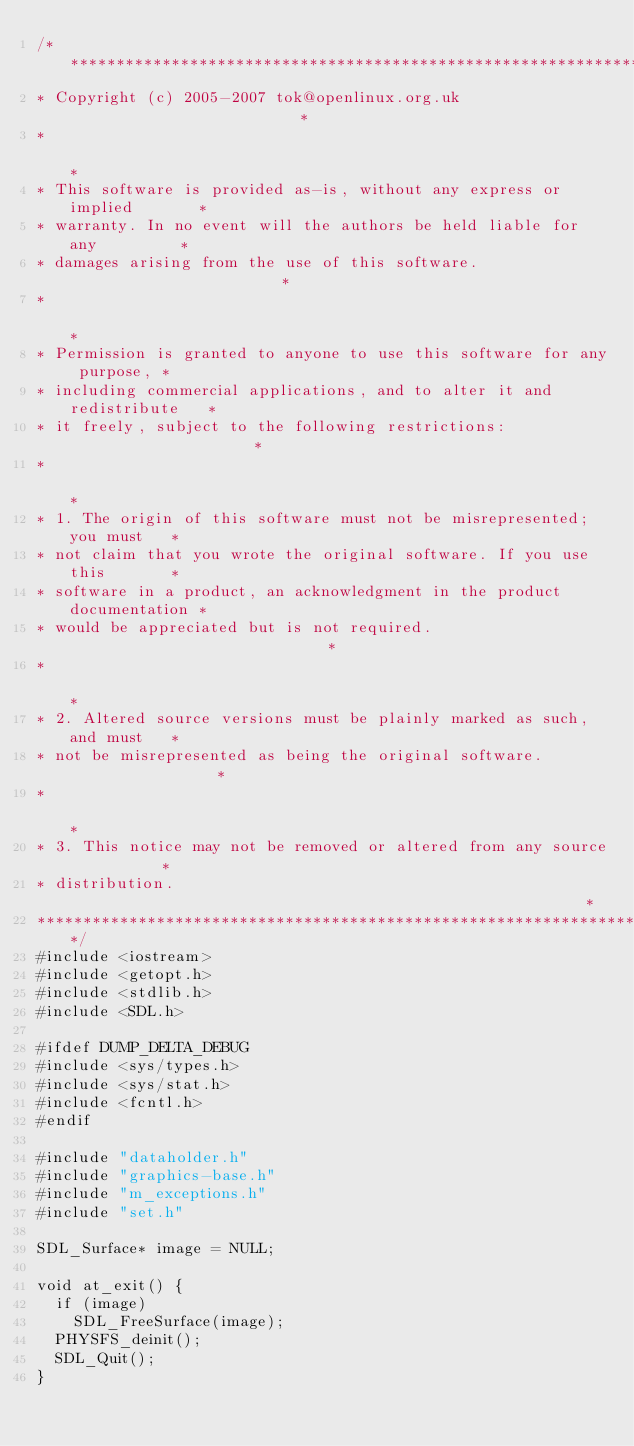Convert code to text. <code><loc_0><loc_0><loc_500><loc_500><_C++_>/************************************************************************
* Copyright (c) 2005-2007 tok@openlinux.org.uk                          *
*                                                                       *
* This software is provided as-is, without any express or implied       *
* warranty. In no event will the authors be held liable for any         *
* damages arising from the use of this software.                        *
*                                                                       *
* Permission is granted to anyone to use this software for any purpose, *
* including commercial applications, and to alter it and redistribute   *
* it freely, subject to the following restrictions:                     *
*                                                                       *
* 1. The origin of this software must not be misrepresented; you must   *
* not claim that you wrote the original software. If you use this       *
* software in a product, an acknowledgment in the product documentation *
* would be appreciated but is not required.                             *
*                                                                       *
* 2. Altered source versions must be plainly marked as such, and must   *
* not be misrepresented as being the original software.                 *
*                                                                       *
* 3. This notice may not be removed or altered from any source          *
* distribution.                                                         *
************************************************************************/
#include <iostream>
#include <getopt.h>
#include <stdlib.h>
#include <SDL.h>

#ifdef DUMP_DELTA_DEBUG
#include <sys/types.h>
#include <sys/stat.h>
#include <fcntl.h>
#endif

#include "dataholder.h"
#include "graphics-base.h"
#include "m_exceptions.h"
#include "set.h"

SDL_Surface* image = NULL;

void at_exit() {
  if (image)
    SDL_FreeSurface(image);
  PHYSFS_deinit();
  SDL_Quit();
}
</code> 